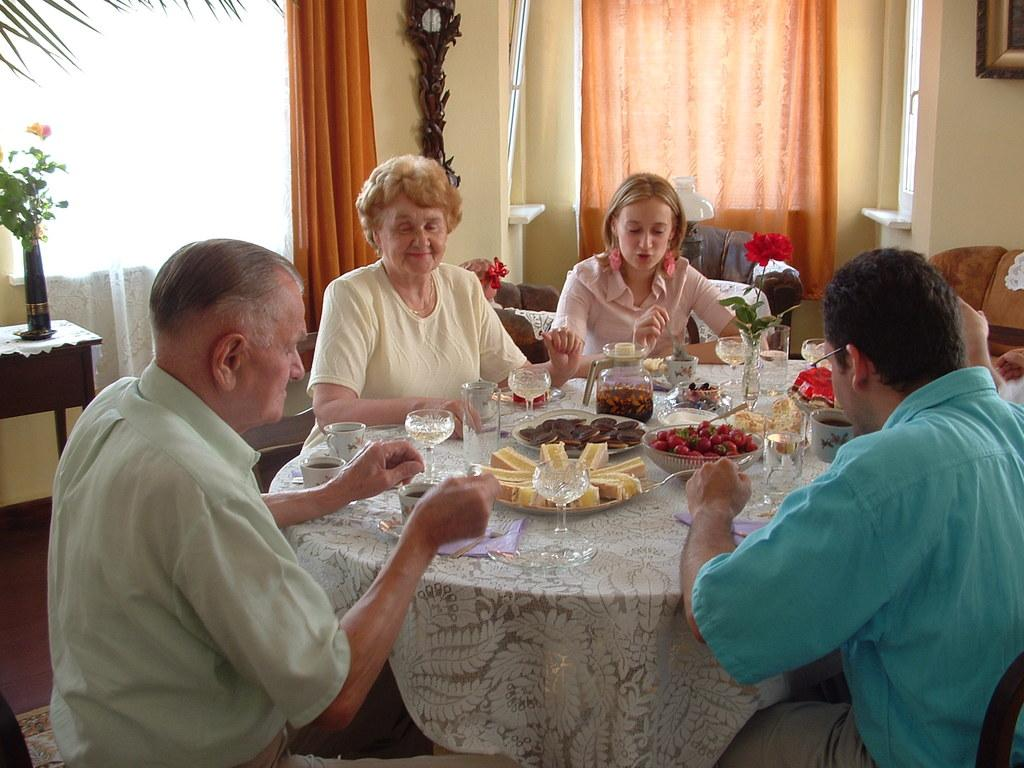What type of structure can be seen in the image? There is a wall in the image. What is another object that can be seen in the image? There is a mirror in the image. What type of window treatment is present in the image? There is a curtain in the image. What are the people in the image doing? There are people sitting on chairs in the image. What is on the table in the image? There are glasses, sweets, plates, and bowls on the table. Can you see the tongue of the person sitting on the chair in the image? There is no indication of a person's tongue being visible in the image. Is there a bean plant growing in the space depicted in the image? There is no bean plant or any reference to space in the image. 